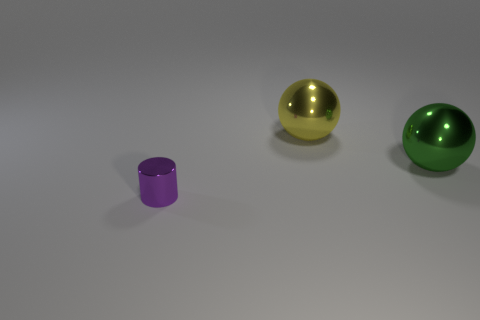What color is the small metal object?
Provide a succinct answer. Purple. Are there any other small purple shiny objects of the same shape as the small thing?
Make the answer very short. No. There is a yellow metallic sphere to the left of the large green sphere; what size is it?
Offer a terse response. Large. There is a ball that is the same size as the yellow shiny object; what material is it?
Keep it short and to the point. Metal. Is the number of large green shiny things greater than the number of tiny green metal balls?
Provide a succinct answer. Yes. What size is the object that is in front of the object that is to the right of the big yellow sphere?
Ensure brevity in your answer.  Small. There is a green thing that is the same size as the yellow ball; what is its shape?
Your answer should be very brief. Sphere. There is a shiny thing on the left side of the sphere behind the big metal sphere in front of the yellow thing; what shape is it?
Give a very brief answer. Cylinder. There is a ball that is in front of the large yellow metallic object; does it have the same color as the shiny thing that is to the left of the yellow metal object?
Offer a very short reply. No. What number of large metallic spheres are there?
Give a very brief answer. 2. 